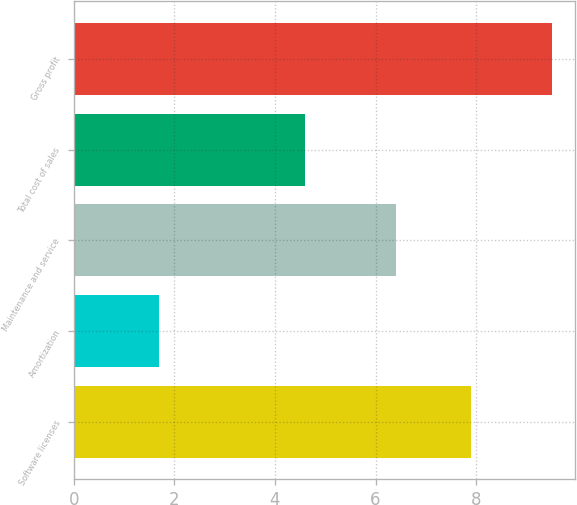<chart> <loc_0><loc_0><loc_500><loc_500><bar_chart><fcel>Software licenses<fcel>Amortization<fcel>Maintenance and service<fcel>Total cost of sales<fcel>Gross profit<nl><fcel>7.9<fcel>1.7<fcel>6.4<fcel>4.6<fcel>9.5<nl></chart> 